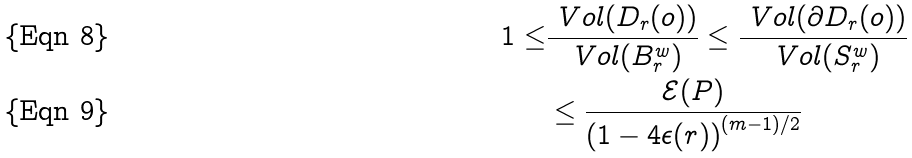<formula> <loc_0><loc_0><loc_500><loc_500>1 \leq & \frac { \ V o l ( D _ { r } ( o ) ) } { \ V o l ( B ^ { w } _ { r } ) } \leq \frac { \ V o l ( \partial D _ { r } ( o ) ) } { \ V o l ( S _ { r } ^ { w } ) } \\ & \leq \frac { \mathcal { E } ( P ) } { \left ( 1 - 4 \epsilon ( r ) \right ) ^ { ( m - 1 ) / 2 } }</formula> 